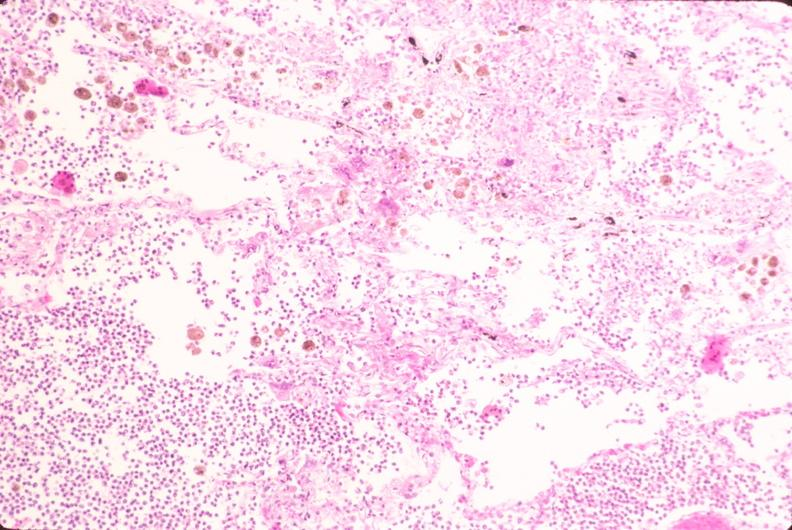where is this?
Answer the question using a single word or phrase. Lung 